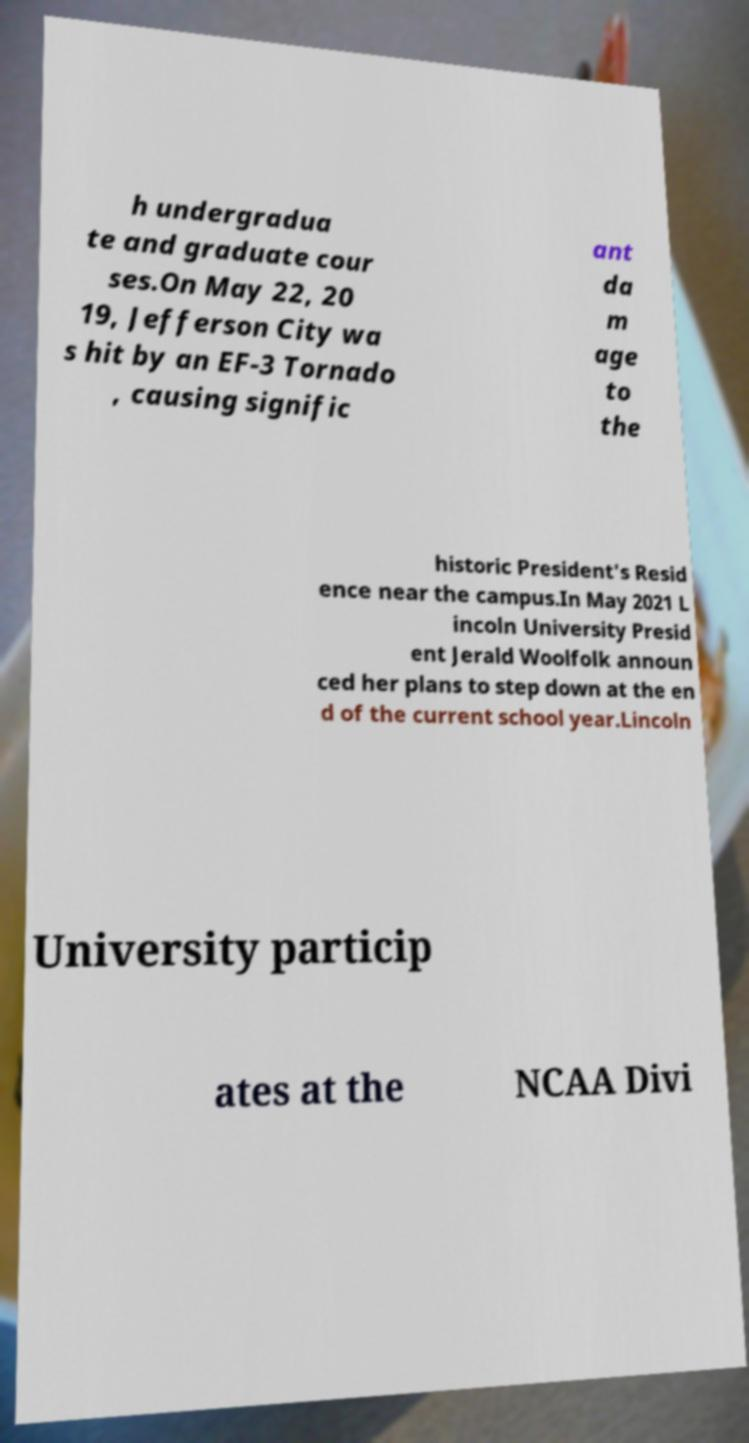Could you extract and type out the text from this image? h undergradua te and graduate cour ses.On May 22, 20 19, Jefferson City wa s hit by an EF-3 Tornado , causing signific ant da m age to the historic President's Resid ence near the campus.In May 2021 L incoln University Presid ent Jerald Woolfolk announ ced her plans to step down at the en d of the current school year.Lincoln University particip ates at the NCAA Divi 